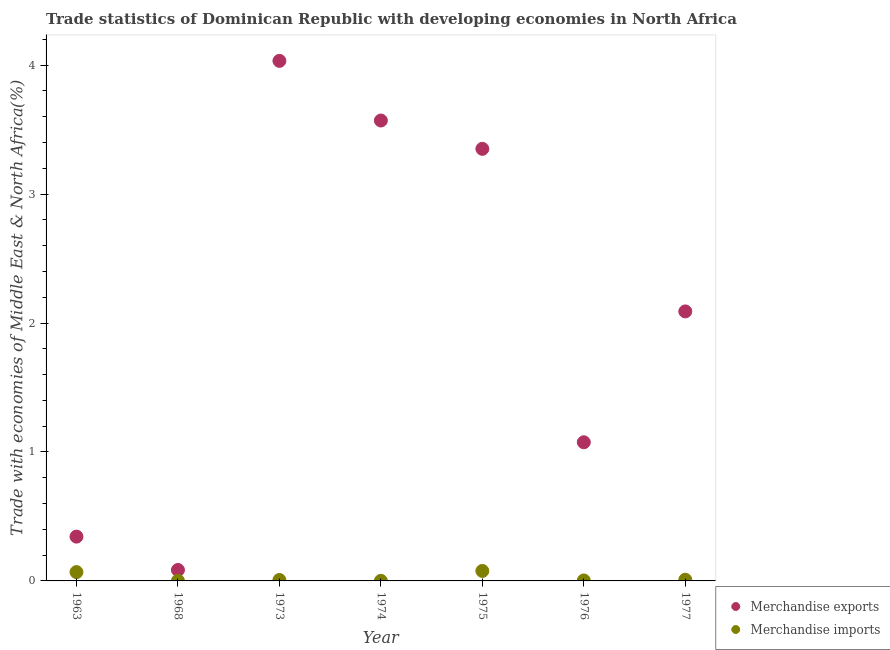How many different coloured dotlines are there?
Your answer should be compact. 2. Is the number of dotlines equal to the number of legend labels?
Your response must be concise. Yes. What is the merchandise exports in 1976?
Offer a very short reply. 1.08. Across all years, what is the maximum merchandise exports?
Ensure brevity in your answer.  4.03. Across all years, what is the minimum merchandise imports?
Give a very brief answer. 0. In which year was the merchandise exports minimum?
Provide a short and direct response. 1968. What is the total merchandise imports in the graph?
Give a very brief answer. 0.17. What is the difference between the merchandise imports in 1963 and that in 1974?
Offer a terse response. 0.07. What is the difference between the merchandise exports in 1975 and the merchandise imports in 1977?
Give a very brief answer. 3.34. What is the average merchandise exports per year?
Offer a terse response. 2.08. In the year 1963, what is the difference between the merchandise imports and merchandise exports?
Offer a terse response. -0.27. What is the ratio of the merchandise exports in 1968 to that in 1974?
Offer a very short reply. 0.02. Is the merchandise imports in 1974 less than that in 1976?
Make the answer very short. Yes. What is the difference between the highest and the second highest merchandise imports?
Provide a succinct answer. 0.01. What is the difference between the highest and the lowest merchandise imports?
Provide a succinct answer. 0.08. In how many years, is the merchandise exports greater than the average merchandise exports taken over all years?
Make the answer very short. 4. Is the sum of the merchandise imports in 1968 and 1974 greater than the maximum merchandise exports across all years?
Offer a very short reply. No. Does the merchandise exports monotonically increase over the years?
Offer a very short reply. No. Is the merchandise exports strictly greater than the merchandise imports over the years?
Offer a very short reply. Yes. How many years are there in the graph?
Your response must be concise. 7. Does the graph contain any zero values?
Offer a very short reply. No. Where does the legend appear in the graph?
Offer a terse response. Bottom right. How are the legend labels stacked?
Give a very brief answer. Vertical. What is the title of the graph?
Offer a very short reply. Trade statistics of Dominican Republic with developing economies in North Africa. What is the label or title of the X-axis?
Your answer should be compact. Year. What is the label or title of the Y-axis?
Offer a terse response. Trade with economies of Middle East & North Africa(%). What is the Trade with economies of Middle East & North Africa(%) of Merchandise exports in 1963?
Your answer should be very brief. 0.34. What is the Trade with economies of Middle East & North Africa(%) in Merchandise imports in 1963?
Provide a short and direct response. 0.07. What is the Trade with economies of Middle East & North Africa(%) in Merchandise exports in 1968?
Offer a terse response. 0.08. What is the Trade with economies of Middle East & North Africa(%) in Merchandise imports in 1968?
Your answer should be very brief. 0. What is the Trade with economies of Middle East & North Africa(%) in Merchandise exports in 1973?
Your answer should be very brief. 4.03. What is the Trade with economies of Middle East & North Africa(%) in Merchandise imports in 1973?
Your answer should be very brief. 0.01. What is the Trade with economies of Middle East & North Africa(%) of Merchandise exports in 1974?
Your answer should be very brief. 3.57. What is the Trade with economies of Middle East & North Africa(%) of Merchandise imports in 1974?
Your answer should be compact. 0. What is the Trade with economies of Middle East & North Africa(%) in Merchandise exports in 1975?
Provide a short and direct response. 3.35. What is the Trade with economies of Middle East & North Africa(%) of Merchandise imports in 1975?
Provide a short and direct response. 0.08. What is the Trade with economies of Middle East & North Africa(%) of Merchandise exports in 1976?
Offer a very short reply. 1.08. What is the Trade with economies of Middle East & North Africa(%) of Merchandise imports in 1976?
Keep it short and to the point. 0. What is the Trade with economies of Middle East & North Africa(%) of Merchandise exports in 1977?
Your answer should be compact. 2.09. What is the Trade with economies of Middle East & North Africa(%) in Merchandise imports in 1977?
Ensure brevity in your answer.  0.01. Across all years, what is the maximum Trade with economies of Middle East & North Africa(%) of Merchandise exports?
Keep it short and to the point. 4.03. Across all years, what is the maximum Trade with economies of Middle East & North Africa(%) of Merchandise imports?
Offer a terse response. 0.08. Across all years, what is the minimum Trade with economies of Middle East & North Africa(%) of Merchandise exports?
Your response must be concise. 0.08. Across all years, what is the minimum Trade with economies of Middle East & North Africa(%) in Merchandise imports?
Offer a very short reply. 0. What is the total Trade with economies of Middle East & North Africa(%) of Merchandise exports in the graph?
Your response must be concise. 14.55. What is the total Trade with economies of Middle East & North Africa(%) of Merchandise imports in the graph?
Your answer should be very brief. 0.17. What is the difference between the Trade with economies of Middle East & North Africa(%) in Merchandise exports in 1963 and that in 1968?
Your answer should be compact. 0.26. What is the difference between the Trade with economies of Middle East & North Africa(%) in Merchandise imports in 1963 and that in 1968?
Offer a terse response. 0.07. What is the difference between the Trade with economies of Middle East & North Africa(%) of Merchandise exports in 1963 and that in 1973?
Make the answer very short. -3.69. What is the difference between the Trade with economies of Middle East & North Africa(%) of Merchandise imports in 1963 and that in 1973?
Provide a short and direct response. 0.06. What is the difference between the Trade with economies of Middle East & North Africa(%) in Merchandise exports in 1963 and that in 1974?
Your answer should be compact. -3.23. What is the difference between the Trade with economies of Middle East & North Africa(%) in Merchandise imports in 1963 and that in 1974?
Provide a succinct answer. 0.07. What is the difference between the Trade with economies of Middle East & North Africa(%) in Merchandise exports in 1963 and that in 1975?
Provide a short and direct response. -3.01. What is the difference between the Trade with economies of Middle East & North Africa(%) in Merchandise imports in 1963 and that in 1975?
Your response must be concise. -0.01. What is the difference between the Trade with economies of Middle East & North Africa(%) of Merchandise exports in 1963 and that in 1976?
Keep it short and to the point. -0.73. What is the difference between the Trade with economies of Middle East & North Africa(%) in Merchandise imports in 1963 and that in 1976?
Your answer should be very brief. 0.07. What is the difference between the Trade with economies of Middle East & North Africa(%) of Merchandise exports in 1963 and that in 1977?
Your response must be concise. -1.75. What is the difference between the Trade with economies of Middle East & North Africa(%) in Merchandise imports in 1963 and that in 1977?
Your answer should be compact. 0.06. What is the difference between the Trade with economies of Middle East & North Africa(%) of Merchandise exports in 1968 and that in 1973?
Make the answer very short. -3.95. What is the difference between the Trade with economies of Middle East & North Africa(%) in Merchandise imports in 1968 and that in 1973?
Keep it short and to the point. -0.01. What is the difference between the Trade with economies of Middle East & North Africa(%) of Merchandise exports in 1968 and that in 1974?
Provide a succinct answer. -3.49. What is the difference between the Trade with economies of Middle East & North Africa(%) in Merchandise imports in 1968 and that in 1974?
Your answer should be compact. 0. What is the difference between the Trade with economies of Middle East & North Africa(%) in Merchandise exports in 1968 and that in 1975?
Your answer should be very brief. -3.27. What is the difference between the Trade with economies of Middle East & North Africa(%) in Merchandise imports in 1968 and that in 1975?
Give a very brief answer. -0.08. What is the difference between the Trade with economies of Middle East & North Africa(%) in Merchandise exports in 1968 and that in 1976?
Your answer should be compact. -0.99. What is the difference between the Trade with economies of Middle East & North Africa(%) of Merchandise imports in 1968 and that in 1976?
Offer a very short reply. -0. What is the difference between the Trade with economies of Middle East & North Africa(%) in Merchandise exports in 1968 and that in 1977?
Offer a very short reply. -2.01. What is the difference between the Trade with economies of Middle East & North Africa(%) of Merchandise imports in 1968 and that in 1977?
Your response must be concise. -0.01. What is the difference between the Trade with economies of Middle East & North Africa(%) in Merchandise exports in 1973 and that in 1974?
Provide a short and direct response. 0.46. What is the difference between the Trade with economies of Middle East & North Africa(%) in Merchandise imports in 1973 and that in 1974?
Make the answer very short. 0.01. What is the difference between the Trade with economies of Middle East & North Africa(%) of Merchandise exports in 1973 and that in 1975?
Your response must be concise. 0.68. What is the difference between the Trade with economies of Middle East & North Africa(%) in Merchandise imports in 1973 and that in 1975?
Keep it short and to the point. -0.07. What is the difference between the Trade with economies of Middle East & North Africa(%) in Merchandise exports in 1973 and that in 1976?
Give a very brief answer. 2.96. What is the difference between the Trade with economies of Middle East & North Africa(%) in Merchandise imports in 1973 and that in 1976?
Provide a succinct answer. 0. What is the difference between the Trade with economies of Middle East & North Africa(%) of Merchandise exports in 1973 and that in 1977?
Make the answer very short. 1.94. What is the difference between the Trade with economies of Middle East & North Africa(%) of Merchandise imports in 1973 and that in 1977?
Offer a terse response. -0. What is the difference between the Trade with economies of Middle East & North Africa(%) in Merchandise exports in 1974 and that in 1975?
Keep it short and to the point. 0.22. What is the difference between the Trade with economies of Middle East & North Africa(%) in Merchandise imports in 1974 and that in 1975?
Provide a succinct answer. -0.08. What is the difference between the Trade with economies of Middle East & North Africa(%) of Merchandise exports in 1974 and that in 1976?
Offer a very short reply. 2.5. What is the difference between the Trade with economies of Middle East & North Africa(%) in Merchandise imports in 1974 and that in 1976?
Your response must be concise. -0. What is the difference between the Trade with economies of Middle East & North Africa(%) in Merchandise exports in 1974 and that in 1977?
Provide a short and direct response. 1.48. What is the difference between the Trade with economies of Middle East & North Africa(%) in Merchandise imports in 1974 and that in 1977?
Ensure brevity in your answer.  -0.01. What is the difference between the Trade with economies of Middle East & North Africa(%) of Merchandise exports in 1975 and that in 1976?
Your answer should be very brief. 2.28. What is the difference between the Trade with economies of Middle East & North Africa(%) in Merchandise imports in 1975 and that in 1976?
Make the answer very short. 0.07. What is the difference between the Trade with economies of Middle East & North Africa(%) in Merchandise exports in 1975 and that in 1977?
Make the answer very short. 1.26. What is the difference between the Trade with economies of Middle East & North Africa(%) in Merchandise imports in 1975 and that in 1977?
Keep it short and to the point. 0.07. What is the difference between the Trade with economies of Middle East & North Africa(%) of Merchandise exports in 1976 and that in 1977?
Ensure brevity in your answer.  -1.01. What is the difference between the Trade with economies of Middle East & North Africa(%) in Merchandise imports in 1976 and that in 1977?
Give a very brief answer. -0.01. What is the difference between the Trade with economies of Middle East & North Africa(%) in Merchandise exports in 1963 and the Trade with economies of Middle East & North Africa(%) in Merchandise imports in 1968?
Make the answer very short. 0.34. What is the difference between the Trade with economies of Middle East & North Africa(%) in Merchandise exports in 1963 and the Trade with economies of Middle East & North Africa(%) in Merchandise imports in 1973?
Ensure brevity in your answer.  0.34. What is the difference between the Trade with economies of Middle East & North Africa(%) of Merchandise exports in 1963 and the Trade with economies of Middle East & North Africa(%) of Merchandise imports in 1974?
Offer a terse response. 0.34. What is the difference between the Trade with economies of Middle East & North Africa(%) in Merchandise exports in 1963 and the Trade with economies of Middle East & North Africa(%) in Merchandise imports in 1975?
Your answer should be very brief. 0.27. What is the difference between the Trade with economies of Middle East & North Africa(%) of Merchandise exports in 1963 and the Trade with economies of Middle East & North Africa(%) of Merchandise imports in 1976?
Keep it short and to the point. 0.34. What is the difference between the Trade with economies of Middle East & North Africa(%) in Merchandise exports in 1963 and the Trade with economies of Middle East & North Africa(%) in Merchandise imports in 1977?
Ensure brevity in your answer.  0.33. What is the difference between the Trade with economies of Middle East & North Africa(%) of Merchandise exports in 1968 and the Trade with economies of Middle East & North Africa(%) of Merchandise imports in 1973?
Your answer should be compact. 0.08. What is the difference between the Trade with economies of Middle East & North Africa(%) of Merchandise exports in 1968 and the Trade with economies of Middle East & North Africa(%) of Merchandise imports in 1974?
Offer a very short reply. 0.08. What is the difference between the Trade with economies of Middle East & North Africa(%) of Merchandise exports in 1968 and the Trade with economies of Middle East & North Africa(%) of Merchandise imports in 1975?
Provide a succinct answer. 0.01. What is the difference between the Trade with economies of Middle East & North Africa(%) in Merchandise exports in 1968 and the Trade with economies of Middle East & North Africa(%) in Merchandise imports in 1976?
Make the answer very short. 0.08. What is the difference between the Trade with economies of Middle East & North Africa(%) of Merchandise exports in 1968 and the Trade with economies of Middle East & North Africa(%) of Merchandise imports in 1977?
Your answer should be very brief. 0.08. What is the difference between the Trade with economies of Middle East & North Africa(%) in Merchandise exports in 1973 and the Trade with economies of Middle East & North Africa(%) in Merchandise imports in 1974?
Ensure brevity in your answer.  4.03. What is the difference between the Trade with economies of Middle East & North Africa(%) of Merchandise exports in 1973 and the Trade with economies of Middle East & North Africa(%) of Merchandise imports in 1975?
Your response must be concise. 3.96. What is the difference between the Trade with economies of Middle East & North Africa(%) in Merchandise exports in 1973 and the Trade with economies of Middle East & North Africa(%) in Merchandise imports in 1976?
Your answer should be very brief. 4.03. What is the difference between the Trade with economies of Middle East & North Africa(%) of Merchandise exports in 1973 and the Trade with economies of Middle East & North Africa(%) of Merchandise imports in 1977?
Keep it short and to the point. 4.02. What is the difference between the Trade with economies of Middle East & North Africa(%) in Merchandise exports in 1974 and the Trade with economies of Middle East & North Africa(%) in Merchandise imports in 1975?
Keep it short and to the point. 3.49. What is the difference between the Trade with economies of Middle East & North Africa(%) in Merchandise exports in 1974 and the Trade with economies of Middle East & North Africa(%) in Merchandise imports in 1976?
Offer a very short reply. 3.57. What is the difference between the Trade with economies of Middle East & North Africa(%) in Merchandise exports in 1974 and the Trade with economies of Middle East & North Africa(%) in Merchandise imports in 1977?
Your answer should be very brief. 3.56. What is the difference between the Trade with economies of Middle East & North Africa(%) of Merchandise exports in 1975 and the Trade with economies of Middle East & North Africa(%) of Merchandise imports in 1976?
Provide a succinct answer. 3.35. What is the difference between the Trade with economies of Middle East & North Africa(%) in Merchandise exports in 1975 and the Trade with economies of Middle East & North Africa(%) in Merchandise imports in 1977?
Ensure brevity in your answer.  3.34. What is the difference between the Trade with economies of Middle East & North Africa(%) of Merchandise exports in 1976 and the Trade with economies of Middle East & North Africa(%) of Merchandise imports in 1977?
Give a very brief answer. 1.07. What is the average Trade with economies of Middle East & North Africa(%) in Merchandise exports per year?
Your answer should be compact. 2.08. What is the average Trade with economies of Middle East & North Africa(%) of Merchandise imports per year?
Offer a very short reply. 0.02. In the year 1963, what is the difference between the Trade with economies of Middle East & North Africa(%) in Merchandise exports and Trade with economies of Middle East & North Africa(%) in Merchandise imports?
Your answer should be very brief. 0.27. In the year 1968, what is the difference between the Trade with economies of Middle East & North Africa(%) in Merchandise exports and Trade with economies of Middle East & North Africa(%) in Merchandise imports?
Ensure brevity in your answer.  0.08. In the year 1973, what is the difference between the Trade with economies of Middle East & North Africa(%) in Merchandise exports and Trade with economies of Middle East & North Africa(%) in Merchandise imports?
Your response must be concise. 4.03. In the year 1974, what is the difference between the Trade with economies of Middle East & North Africa(%) of Merchandise exports and Trade with economies of Middle East & North Africa(%) of Merchandise imports?
Your answer should be very brief. 3.57. In the year 1975, what is the difference between the Trade with economies of Middle East & North Africa(%) in Merchandise exports and Trade with economies of Middle East & North Africa(%) in Merchandise imports?
Provide a succinct answer. 3.27. In the year 1976, what is the difference between the Trade with economies of Middle East & North Africa(%) of Merchandise exports and Trade with economies of Middle East & North Africa(%) of Merchandise imports?
Your answer should be compact. 1.07. In the year 1977, what is the difference between the Trade with economies of Middle East & North Africa(%) in Merchandise exports and Trade with economies of Middle East & North Africa(%) in Merchandise imports?
Your response must be concise. 2.08. What is the ratio of the Trade with economies of Middle East & North Africa(%) in Merchandise exports in 1963 to that in 1968?
Provide a succinct answer. 4.05. What is the ratio of the Trade with economies of Middle East & North Africa(%) in Merchandise imports in 1963 to that in 1968?
Provide a short and direct response. 63.46. What is the ratio of the Trade with economies of Middle East & North Africa(%) of Merchandise exports in 1963 to that in 1973?
Provide a succinct answer. 0.09. What is the ratio of the Trade with economies of Middle East & North Africa(%) of Merchandise imports in 1963 to that in 1973?
Provide a short and direct response. 9.43. What is the ratio of the Trade with economies of Middle East & North Africa(%) of Merchandise exports in 1963 to that in 1974?
Provide a succinct answer. 0.1. What is the ratio of the Trade with economies of Middle East & North Africa(%) in Merchandise imports in 1963 to that in 1974?
Your response must be concise. 96.34. What is the ratio of the Trade with economies of Middle East & North Africa(%) in Merchandise exports in 1963 to that in 1975?
Offer a very short reply. 0.1. What is the ratio of the Trade with economies of Middle East & North Africa(%) of Merchandise imports in 1963 to that in 1975?
Offer a terse response. 0.89. What is the ratio of the Trade with economies of Middle East & North Africa(%) of Merchandise exports in 1963 to that in 1976?
Ensure brevity in your answer.  0.32. What is the ratio of the Trade with economies of Middle East & North Africa(%) of Merchandise imports in 1963 to that in 1976?
Make the answer very short. 19.4. What is the ratio of the Trade with economies of Middle East & North Africa(%) of Merchandise exports in 1963 to that in 1977?
Keep it short and to the point. 0.16. What is the ratio of the Trade with economies of Middle East & North Africa(%) in Merchandise imports in 1963 to that in 1977?
Provide a short and direct response. 7.36. What is the ratio of the Trade with economies of Middle East & North Africa(%) of Merchandise exports in 1968 to that in 1973?
Provide a short and direct response. 0.02. What is the ratio of the Trade with economies of Middle East & North Africa(%) in Merchandise imports in 1968 to that in 1973?
Your response must be concise. 0.15. What is the ratio of the Trade with economies of Middle East & North Africa(%) of Merchandise exports in 1968 to that in 1974?
Your response must be concise. 0.02. What is the ratio of the Trade with economies of Middle East & North Africa(%) in Merchandise imports in 1968 to that in 1974?
Your answer should be very brief. 1.52. What is the ratio of the Trade with economies of Middle East & North Africa(%) of Merchandise exports in 1968 to that in 1975?
Offer a terse response. 0.03. What is the ratio of the Trade with economies of Middle East & North Africa(%) of Merchandise imports in 1968 to that in 1975?
Provide a succinct answer. 0.01. What is the ratio of the Trade with economies of Middle East & North Africa(%) of Merchandise exports in 1968 to that in 1976?
Give a very brief answer. 0.08. What is the ratio of the Trade with economies of Middle East & North Africa(%) of Merchandise imports in 1968 to that in 1976?
Give a very brief answer. 0.31. What is the ratio of the Trade with economies of Middle East & North Africa(%) in Merchandise exports in 1968 to that in 1977?
Offer a terse response. 0.04. What is the ratio of the Trade with economies of Middle East & North Africa(%) of Merchandise imports in 1968 to that in 1977?
Provide a short and direct response. 0.12. What is the ratio of the Trade with economies of Middle East & North Africa(%) in Merchandise exports in 1973 to that in 1974?
Keep it short and to the point. 1.13. What is the ratio of the Trade with economies of Middle East & North Africa(%) of Merchandise imports in 1973 to that in 1974?
Make the answer very short. 10.22. What is the ratio of the Trade with economies of Middle East & North Africa(%) of Merchandise exports in 1973 to that in 1975?
Offer a very short reply. 1.2. What is the ratio of the Trade with economies of Middle East & North Africa(%) of Merchandise imports in 1973 to that in 1975?
Make the answer very short. 0.09. What is the ratio of the Trade with economies of Middle East & North Africa(%) in Merchandise exports in 1973 to that in 1976?
Keep it short and to the point. 3.75. What is the ratio of the Trade with economies of Middle East & North Africa(%) in Merchandise imports in 1973 to that in 1976?
Keep it short and to the point. 2.06. What is the ratio of the Trade with economies of Middle East & North Africa(%) in Merchandise exports in 1973 to that in 1977?
Give a very brief answer. 1.93. What is the ratio of the Trade with economies of Middle East & North Africa(%) in Merchandise imports in 1973 to that in 1977?
Provide a short and direct response. 0.78. What is the ratio of the Trade with economies of Middle East & North Africa(%) of Merchandise exports in 1974 to that in 1975?
Keep it short and to the point. 1.07. What is the ratio of the Trade with economies of Middle East & North Africa(%) in Merchandise imports in 1974 to that in 1975?
Your answer should be compact. 0.01. What is the ratio of the Trade with economies of Middle East & North Africa(%) of Merchandise exports in 1974 to that in 1976?
Your answer should be compact. 3.32. What is the ratio of the Trade with economies of Middle East & North Africa(%) in Merchandise imports in 1974 to that in 1976?
Provide a succinct answer. 0.2. What is the ratio of the Trade with economies of Middle East & North Africa(%) in Merchandise exports in 1974 to that in 1977?
Your answer should be very brief. 1.71. What is the ratio of the Trade with economies of Middle East & North Africa(%) of Merchandise imports in 1974 to that in 1977?
Provide a short and direct response. 0.08. What is the ratio of the Trade with economies of Middle East & North Africa(%) in Merchandise exports in 1975 to that in 1976?
Offer a terse response. 3.12. What is the ratio of the Trade with economies of Middle East & North Africa(%) in Merchandise imports in 1975 to that in 1976?
Make the answer very short. 21.9. What is the ratio of the Trade with economies of Middle East & North Africa(%) in Merchandise exports in 1975 to that in 1977?
Offer a very short reply. 1.6. What is the ratio of the Trade with economies of Middle East & North Africa(%) in Merchandise imports in 1975 to that in 1977?
Offer a very short reply. 8.31. What is the ratio of the Trade with economies of Middle East & North Africa(%) of Merchandise exports in 1976 to that in 1977?
Make the answer very short. 0.51. What is the ratio of the Trade with economies of Middle East & North Africa(%) of Merchandise imports in 1976 to that in 1977?
Give a very brief answer. 0.38. What is the difference between the highest and the second highest Trade with economies of Middle East & North Africa(%) in Merchandise exports?
Keep it short and to the point. 0.46. What is the difference between the highest and the second highest Trade with economies of Middle East & North Africa(%) of Merchandise imports?
Your answer should be very brief. 0.01. What is the difference between the highest and the lowest Trade with economies of Middle East & North Africa(%) of Merchandise exports?
Ensure brevity in your answer.  3.95. What is the difference between the highest and the lowest Trade with economies of Middle East & North Africa(%) in Merchandise imports?
Offer a terse response. 0.08. 